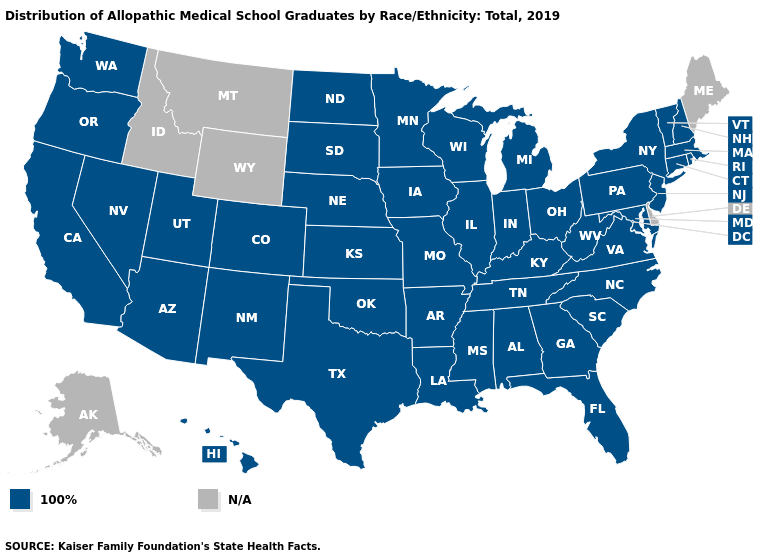Name the states that have a value in the range 100%?
Give a very brief answer. Alabama, Arizona, Arkansas, California, Colorado, Connecticut, Florida, Georgia, Hawaii, Illinois, Indiana, Iowa, Kansas, Kentucky, Louisiana, Maryland, Massachusetts, Michigan, Minnesota, Mississippi, Missouri, Nebraska, Nevada, New Hampshire, New Jersey, New Mexico, New York, North Carolina, North Dakota, Ohio, Oklahoma, Oregon, Pennsylvania, Rhode Island, South Carolina, South Dakota, Tennessee, Texas, Utah, Vermont, Virginia, Washington, West Virginia, Wisconsin. What is the value of New Mexico?
Write a very short answer. 100%. Name the states that have a value in the range 100%?
Be succinct. Alabama, Arizona, Arkansas, California, Colorado, Connecticut, Florida, Georgia, Hawaii, Illinois, Indiana, Iowa, Kansas, Kentucky, Louisiana, Maryland, Massachusetts, Michigan, Minnesota, Mississippi, Missouri, Nebraska, Nevada, New Hampshire, New Jersey, New Mexico, New York, North Carolina, North Dakota, Ohio, Oklahoma, Oregon, Pennsylvania, Rhode Island, South Carolina, South Dakota, Tennessee, Texas, Utah, Vermont, Virginia, Washington, West Virginia, Wisconsin. What is the lowest value in states that border Texas?
Give a very brief answer. 100%. Which states have the lowest value in the South?
Write a very short answer. Alabama, Arkansas, Florida, Georgia, Kentucky, Louisiana, Maryland, Mississippi, North Carolina, Oklahoma, South Carolina, Tennessee, Texas, Virginia, West Virginia. What is the value of Connecticut?
Short answer required. 100%. Which states hav the highest value in the MidWest?
Keep it brief. Illinois, Indiana, Iowa, Kansas, Michigan, Minnesota, Missouri, Nebraska, North Dakota, Ohio, South Dakota, Wisconsin. Name the states that have a value in the range N/A?
Give a very brief answer. Alaska, Delaware, Idaho, Maine, Montana, Wyoming. What is the value of Idaho?
Give a very brief answer. N/A. What is the lowest value in the USA?
Answer briefly. 100%. What is the value of Oregon?
Give a very brief answer. 100%. 